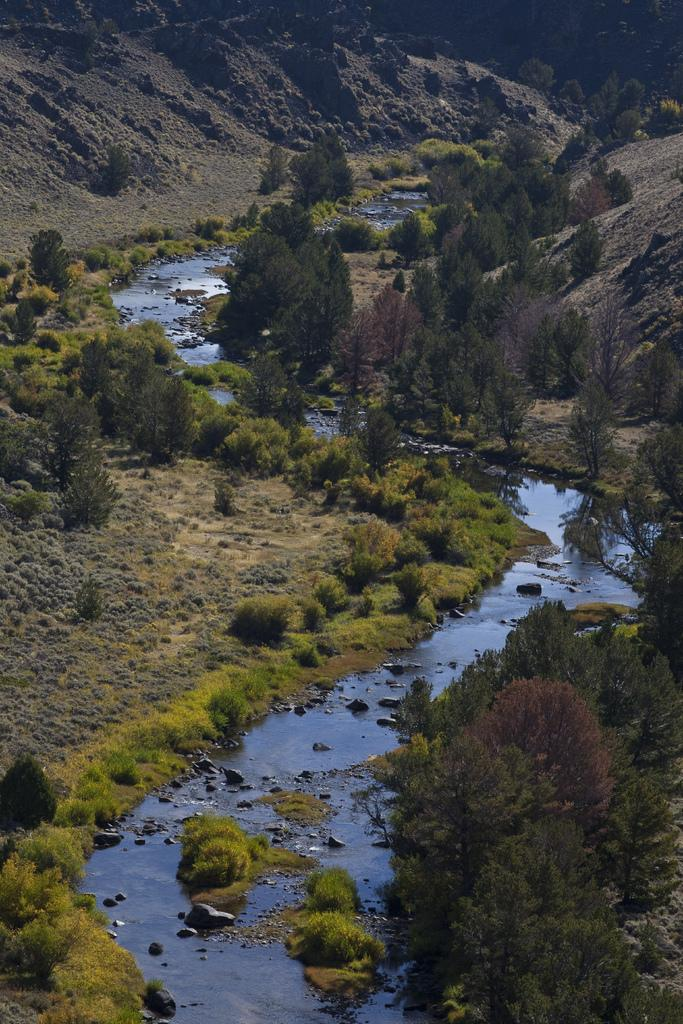What is the main feature in the center of the image? There is a canal in the center of the image. What can be seen in the background of the image? There are trees and hills visible in the background of the image. What type of cord is being used to light the match in the image? There is no cord or match present in the image; it features a canal and background elements. 